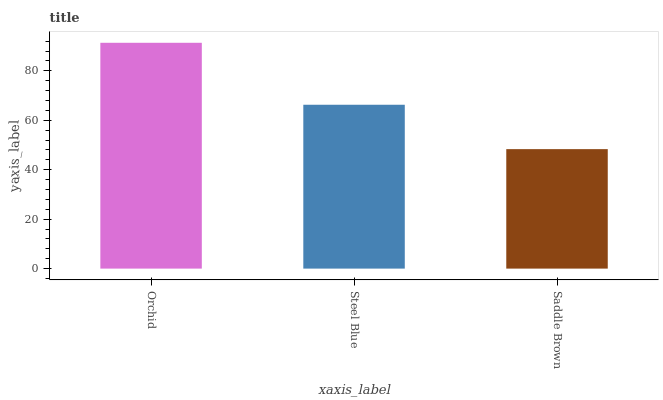Is Steel Blue the minimum?
Answer yes or no. No. Is Steel Blue the maximum?
Answer yes or no. No. Is Orchid greater than Steel Blue?
Answer yes or no. Yes. Is Steel Blue less than Orchid?
Answer yes or no. Yes. Is Steel Blue greater than Orchid?
Answer yes or no. No. Is Orchid less than Steel Blue?
Answer yes or no. No. Is Steel Blue the high median?
Answer yes or no. Yes. Is Steel Blue the low median?
Answer yes or no. Yes. Is Saddle Brown the high median?
Answer yes or no. No. Is Saddle Brown the low median?
Answer yes or no. No. 